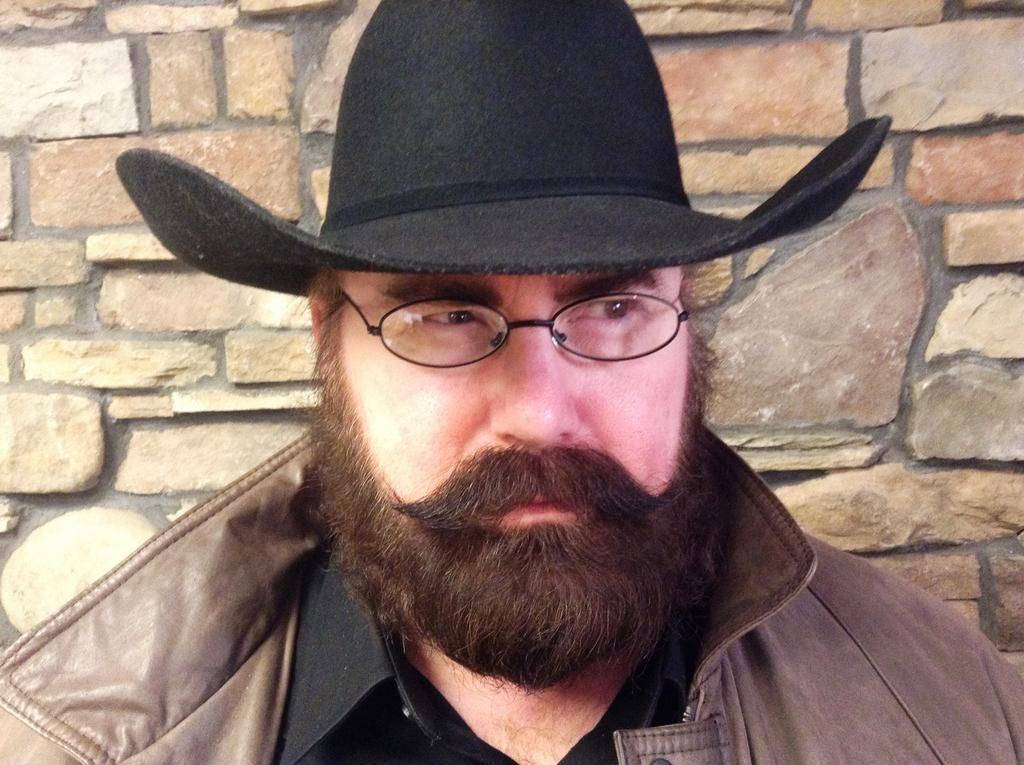Describe this image in one or two sentences. In this image I can see a person is wearing brown and black color dress and black cap. Back I can see a brick wall. 